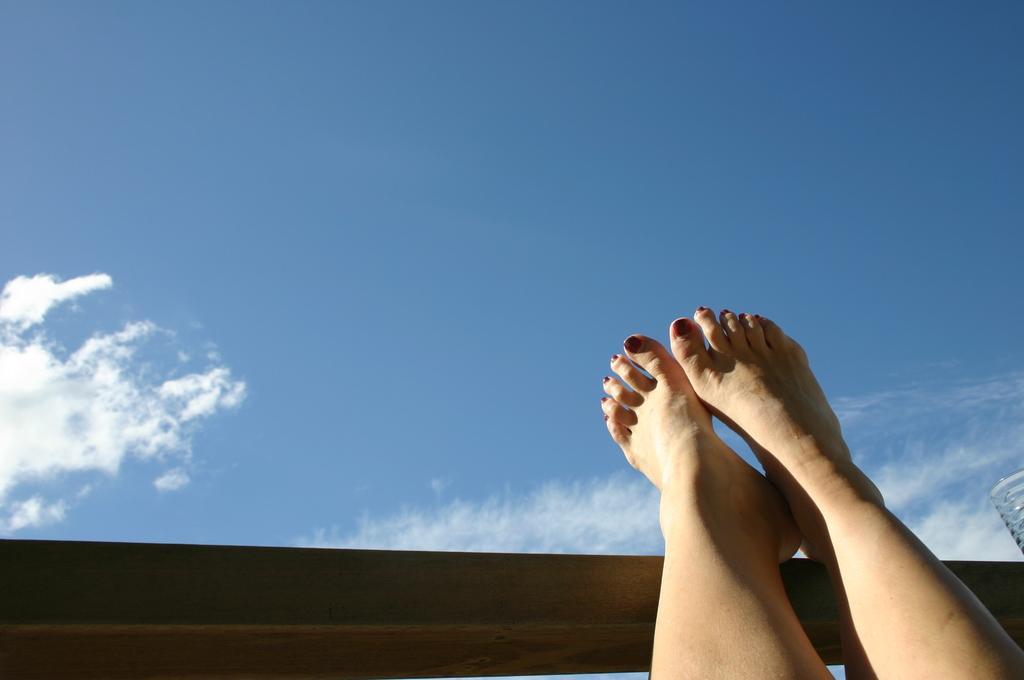Can you describe this image briefly? In the image there is a person hanging legs in the air, it seems to be a wall in front of it and above its sky with clouds. 